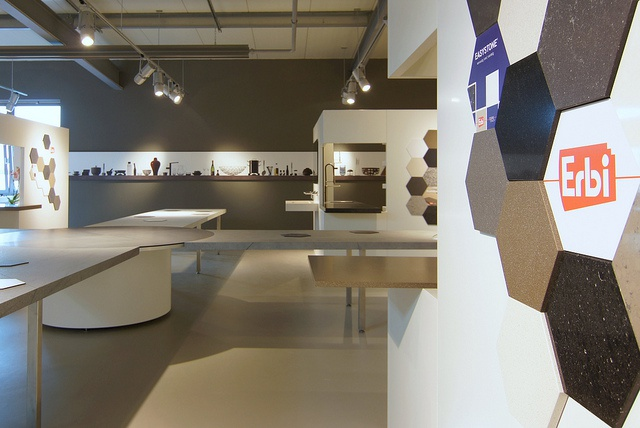Describe the objects in this image and their specific colors. I can see dining table in gray and darkgray tones, dining table in gray, darkgray, and white tones, sink in gray and tan tones, bowl in gray, lightgray, and tan tones, and vase in gray, maroon, black, and lavender tones in this image. 